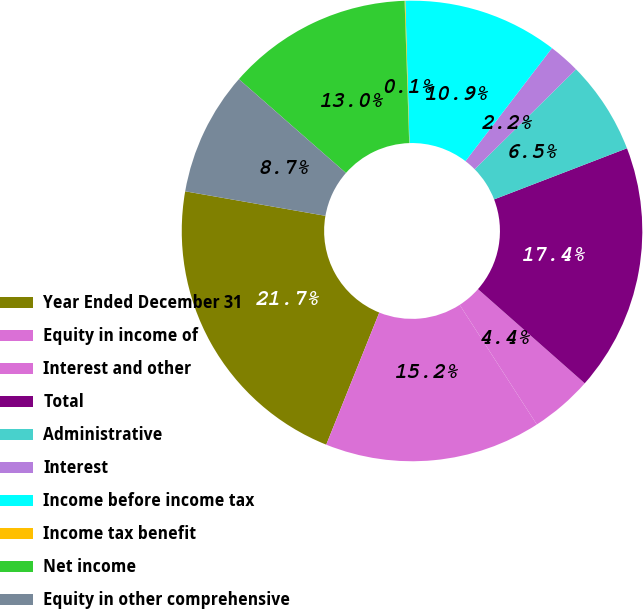Convert chart. <chart><loc_0><loc_0><loc_500><loc_500><pie_chart><fcel>Year Ended December 31<fcel>Equity in income of<fcel>Interest and other<fcel>Total<fcel>Administrative<fcel>Interest<fcel>Income before income tax<fcel>Income tax benefit<fcel>Net income<fcel>Equity in other comprehensive<nl><fcel>21.68%<fcel>15.19%<fcel>4.38%<fcel>17.35%<fcel>6.54%<fcel>2.22%<fcel>10.86%<fcel>0.05%<fcel>13.03%<fcel>8.7%<nl></chart> 